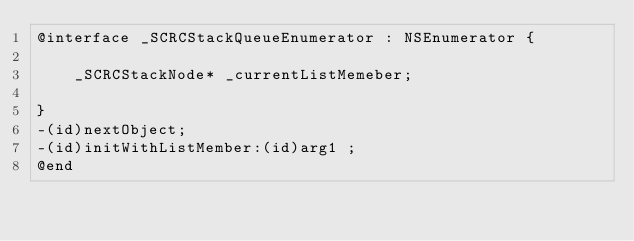<code> <loc_0><loc_0><loc_500><loc_500><_C_>@interface _SCRCStackQueueEnumerator : NSEnumerator {

	_SCRCStackNode* _currentListMemeber;

}
-(id)nextObject;
-(id)initWithListMember:(id)arg1 ;
@end

</code> 